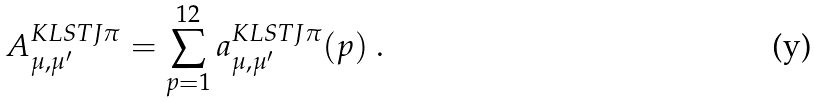Convert formula to latex. <formula><loc_0><loc_0><loc_500><loc_500>A ^ { K L S T J \pi } _ { \mu , \mu ^ { \prime } } = \sum _ { p = 1 } ^ { 1 2 } a ^ { K L S T J \pi } _ { \mu , \mu ^ { \prime } } ( p ) \ .</formula> 